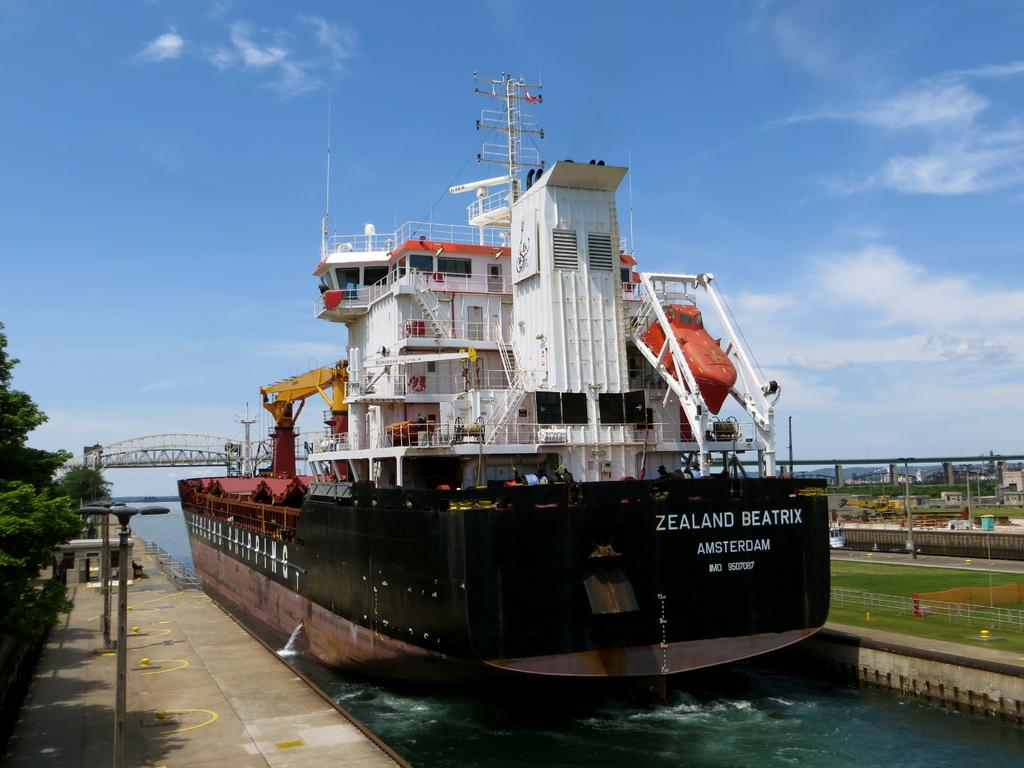<image>
Write a terse but informative summary of the picture. A large ship is docked and says Zealand Beatrix Amsterdam. 